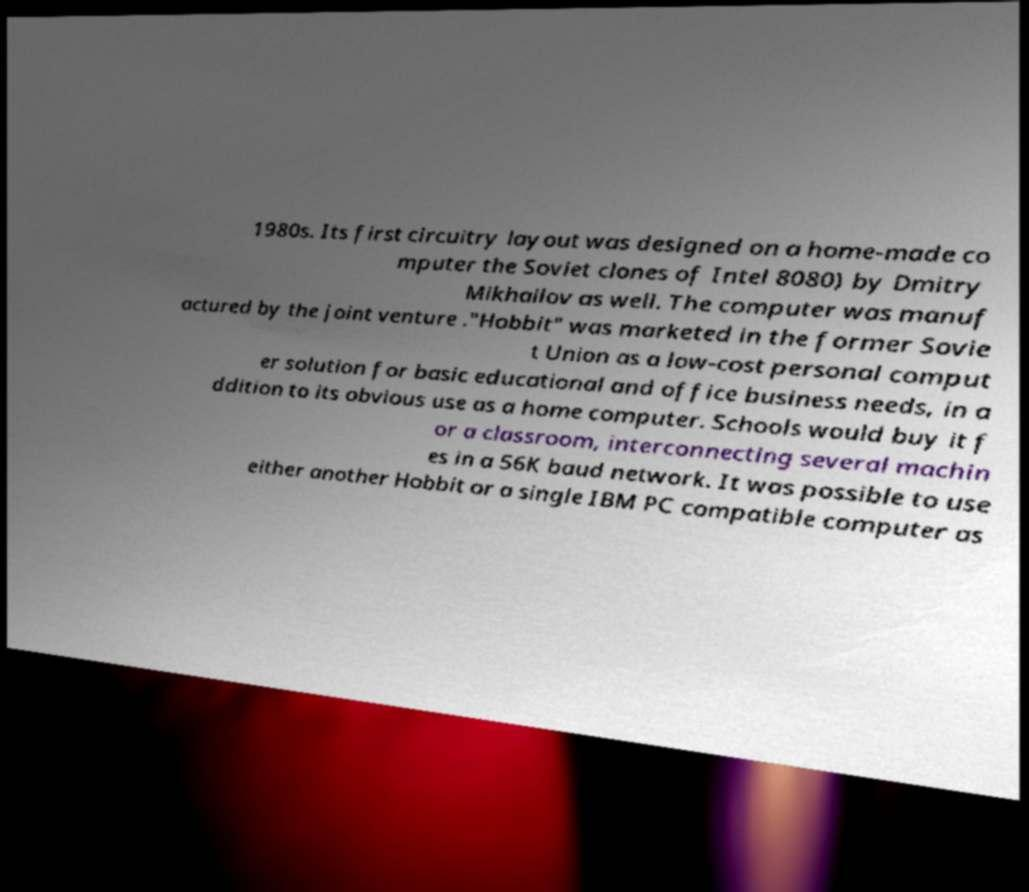There's text embedded in this image that I need extracted. Can you transcribe it verbatim? 1980s. Its first circuitry layout was designed on a home-made co mputer the Soviet clones of Intel 8080) by Dmitry Mikhailov as well. The computer was manuf actured by the joint venture ."Hobbit" was marketed in the former Sovie t Union as a low-cost personal comput er solution for basic educational and office business needs, in a ddition to its obvious use as a home computer. Schools would buy it f or a classroom, interconnecting several machin es in a 56K baud network. It was possible to use either another Hobbit or a single IBM PC compatible computer as 